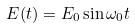Convert formula to latex. <formula><loc_0><loc_0><loc_500><loc_500>E ( t ) = E _ { 0 } \sin \omega _ { 0 } t</formula> 